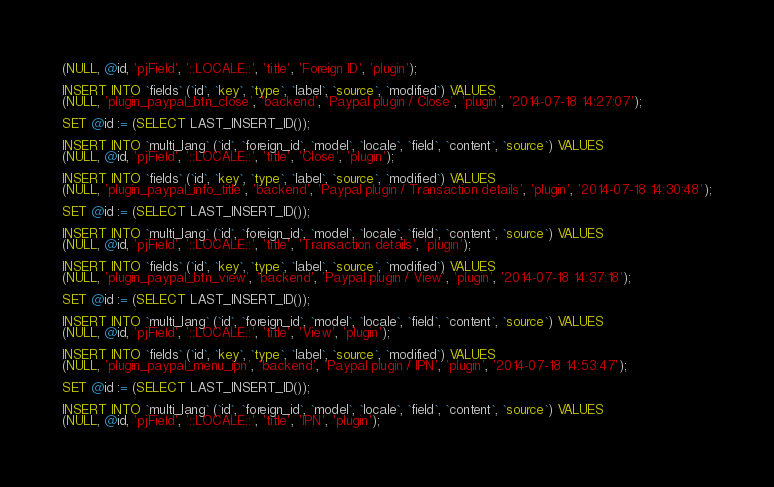<code> <loc_0><loc_0><loc_500><loc_500><_SQL_>(NULL, @id, 'pjField', '::LOCALE::', 'title', 'Foreign ID', 'plugin');

INSERT INTO `fields` (`id`, `key`, `type`, `label`, `source`, `modified`) VALUES
(NULL, 'plugin_paypal_btn_close', 'backend', 'Paypal plugin / Close', 'plugin', '2014-07-18 14:27:07');

SET @id := (SELECT LAST_INSERT_ID());

INSERT INTO `multi_lang` (`id`, `foreign_id`, `model`, `locale`, `field`, `content`, `source`) VALUES
(NULL, @id, 'pjField', '::LOCALE::', 'title', 'Close', 'plugin');

INSERT INTO `fields` (`id`, `key`, `type`, `label`, `source`, `modified`) VALUES
(NULL, 'plugin_paypal_info_title', 'backend', 'Paypal plugin / Transaction details', 'plugin', '2014-07-18 14:30:48');

SET @id := (SELECT LAST_INSERT_ID());

INSERT INTO `multi_lang` (`id`, `foreign_id`, `model`, `locale`, `field`, `content`, `source`) VALUES
(NULL, @id, 'pjField', '::LOCALE::', 'title', 'Transaction details', 'plugin');

INSERT INTO `fields` (`id`, `key`, `type`, `label`, `source`, `modified`) VALUES
(NULL, 'plugin_paypal_btn_view', 'backend', 'Paypal plugin / View', 'plugin', '2014-07-18 14:37:18');

SET @id := (SELECT LAST_INSERT_ID());

INSERT INTO `multi_lang` (`id`, `foreign_id`, `model`, `locale`, `field`, `content`, `source`) VALUES
(NULL, @id, 'pjField', '::LOCALE::', 'title', 'View', 'plugin');

INSERT INTO `fields` (`id`, `key`, `type`, `label`, `source`, `modified`) VALUES
(NULL, 'plugin_paypal_menu_ipn', 'backend', 'Paypal plugin / IPN', 'plugin', '2014-07-18 14:53:47');

SET @id := (SELECT LAST_INSERT_ID());

INSERT INTO `multi_lang` (`id`, `foreign_id`, `model`, `locale`, `field`, `content`, `source`) VALUES
(NULL, @id, 'pjField', '::LOCALE::', 'title', 'IPN', 'plugin');</code> 